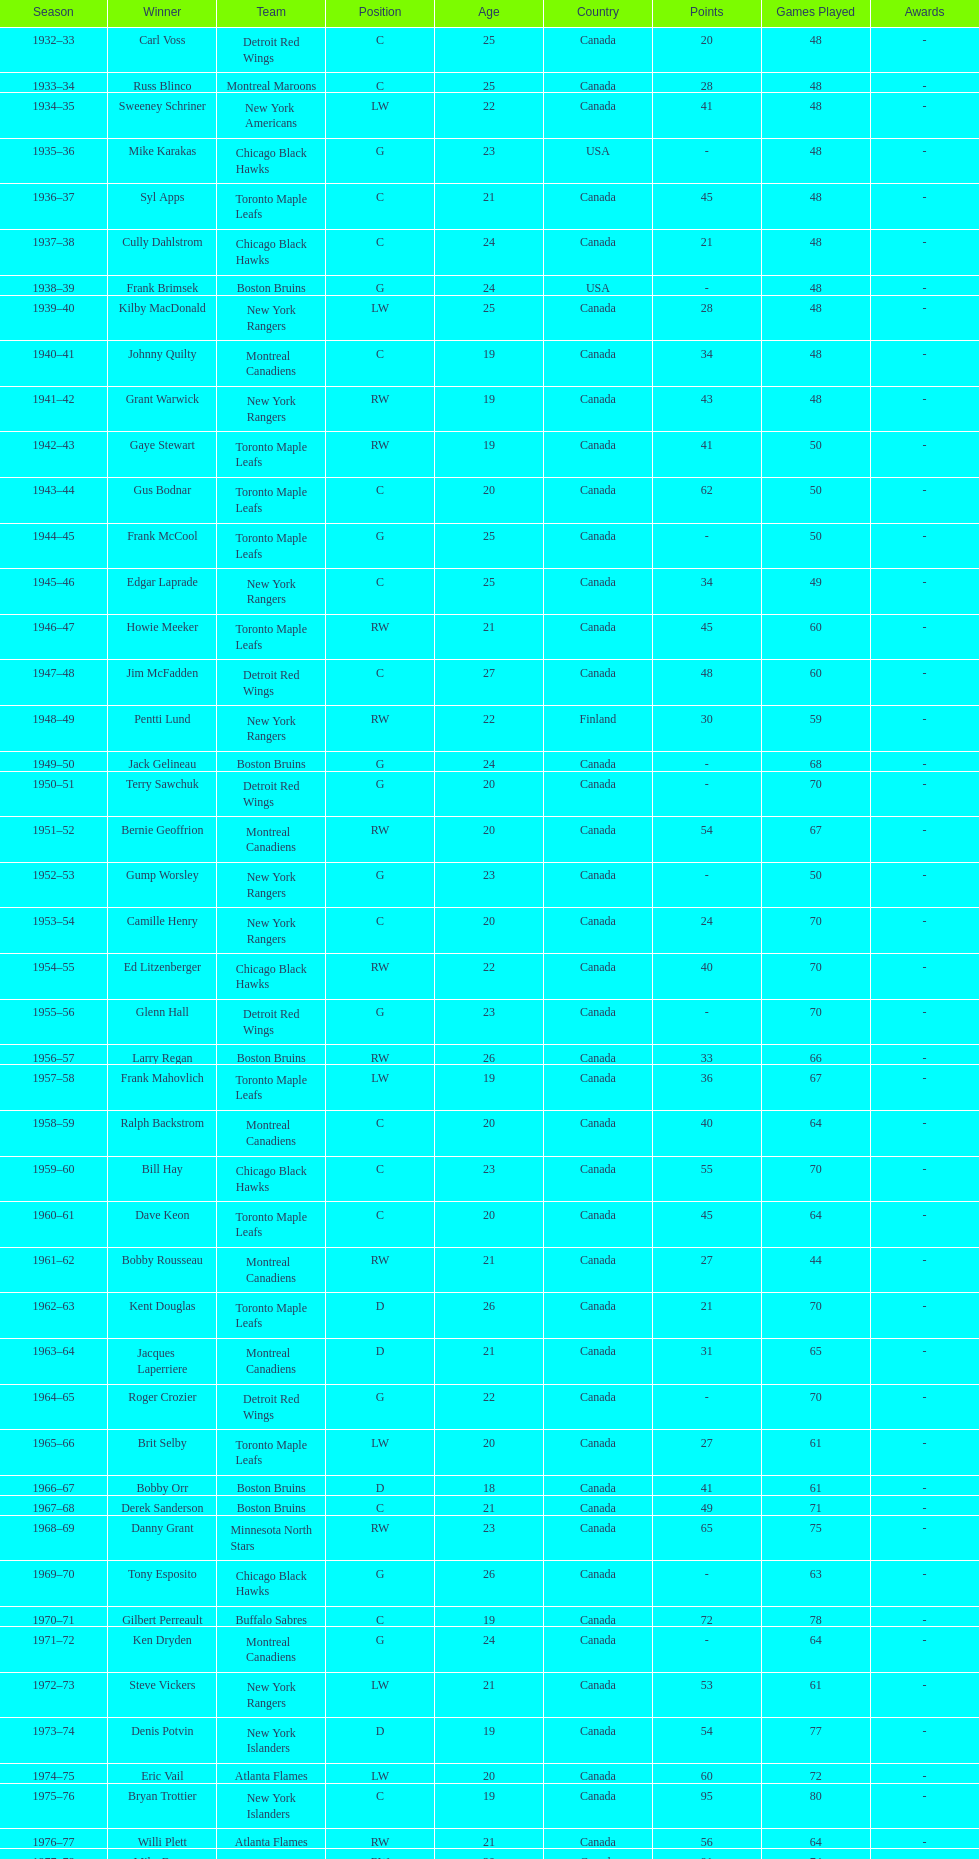Would you mind parsing the complete table? {'header': ['Season', 'Winner', 'Team', 'Position', 'Age', 'Country', 'Points', 'Games Played', 'Awards'], 'rows': [['1932–33', 'Carl Voss', 'Detroit Red Wings', 'C', '25', 'Canada', '20', '48', '-'], ['1933–34', 'Russ Blinco', 'Montreal Maroons', 'C', '25', 'Canada', '28', '48', '-'], ['1934–35', 'Sweeney Schriner', 'New York Americans', 'LW', '22', 'Canada', '41', '48', '-'], ['1935–36', 'Mike Karakas', 'Chicago Black Hawks', 'G', '23', 'USA', '-', '48', '-'], ['1936–37', 'Syl Apps', 'Toronto Maple Leafs', 'C', '21', 'Canada', '45', '48', '-'], ['1937–38', 'Cully Dahlstrom', 'Chicago Black Hawks', 'C', '24', 'Canada', '21', '48', '-'], ['1938–39', 'Frank Brimsek', 'Boston Bruins', 'G', '24', 'USA', '-', '48', '-'], ['1939–40', 'Kilby MacDonald', 'New York Rangers', 'LW', '25', 'Canada', '28', '48', '-'], ['1940–41', 'Johnny Quilty', 'Montreal Canadiens', 'C', '19', 'Canada', '34', '48', '-'], ['1941–42', 'Grant Warwick', 'New York Rangers', 'RW', '19', 'Canada', '43', '48', '-'], ['1942–43', 'Gaye Stewart', 'Toronto Maple Leafs', 'RW', '19', 'Canada', '41', '50', '-'], ['1943–44', 'Gus Bodnar', 'Toronto Maple Leafs', 'C', '20', 'Canada', '62', '50', '-'], ['1944–45', 'Frank McCool', 'Toronto Maple Leafs', 'G', '25', 'Canada', '-', '50', '-'], ['1945–46', 'Edgar Laprade', 'New York Rangers', 'C', '25', 'Canada', '34', '49', '-'], ['1946–47', 'Howie Meeker', 'Toronto Maple Leafs', 'RW', '21', 'Canada', '45', '60', '-'], ['1947–48', 'Jim McFadden', 'Detroit Red Wings', 'C', '27', 'Canada', '48', '60', '-'], ['1948–49', 'Pentti Lund', 'New York Rangers', 'RW', '22', 'Finland', '30', '59', '-'], ['1949–50', 'Jack Gelineau', 'Boston Bruins', 'G', '24', 'Canada', '-', '68', '-'], ['1950–51', 'Terry Sawchuk', 'Detroit Red Wings', 'G', '20', 'Canada', '-', '70', '-'], ['1951–52', 'Bernie Geoffrion', 'Montreal Canadiens', 'RW', '20', 'Canada', '54', '67', '-'], ['1952–53', 'Gump Worsley', 'New York Rangers', 'G', '23', 'Canada', '-', '50', '-'], ['1953–54', 'Camille Henry', 'New York Rangers', 'C', '20', 'Canada', '24', '70', '-'], ['1954–55', 'Ed Litzenberger', 'Chicago Black Hawks', 'RW', '22', 'Canada', '40', '70', '-'], ['1955–56', 'Glenn Hall', 'Detroit Red Wings', 'G', '23', 'Canada', '-', '70', '-'], ['1956–57', 'Larry Regan', 'Boston Bruins', 'RW', '26', 'Canada', '33', '66', '-'], ['1957–58', 'Frank Mahovlich', 'Toronto Maple Leafs', 'LW', '19', 'Canada', '36', '67', '-'], ['1958–59', 'Ralph Backstrom', 'Montreal Canadiens', 'C', '20', 'Canada', '40', '64', '-'], ['1959–60', 'Bill Hay', 'Chicago Black Hawks', 'C', '23', 'Canada', '55', '70', '-'], ['1960–61', 'Dave Keon', 'Toronto Maple Leafs', 'C', '20', 'Canada', '45', '64', '-'], ['1961–62', 'Bobby Rousseau', 'Montreal Canadiens', 'RW', '21', 'Canada', '27', '44', '-'], ['1962–63', 'Kent Douglas', 'Toronto Maple Leafs', 'D', '26', 'Canada', '21', '70', '-'], ['1963–64', 'Jacques Laperriere', 'Montreal Canadiens', 'D', '21', 'Canada', '31', '65', '-'], ['1964–65', 'Roger Crozier', 'Detroit Red Wings', 'G', '22', 'Canada', '-', '70', '-'], ['1965–66', 'Brit Selby', 'Toronto Maple Leafs', 'LW', '20', 'Canada', '27', '61', '-'], ['1966–67', 'Bobby Orr', 'Boston Bruins', 'D', '18', 'Canada', '41', '61', '-'], ['1967–68', 'Derek Sanderson', 'Boston Bruins', 'C', '21', 'Canada', '49', '71', '-'], ['1968–69', 'Danny Grant', 'Minnesota North Stars', 'RW', '23', 'Canada', '65', '75', '-'], ['1969–70', 'Tony Esposito', 'Chicago Black Hawks', 'G', '26', 'Canada', '-', '63', '-'], ['1970–71', 'Gilbert Perreault', 'Buffalo Sabres', 'C', '19', 'Canada', '72', '78', '-'], ['1971–72', 'Ken Dryden', 'Montreal Canadiens', 'G', '24', 'Canada', '-', '64', '-'], ['1972–73', 'Steve Vickers', 'New York Rangers', 'LW', '21', 'Canada', '53', '61', '-'], ['1973–74', 'Denis Potvin', 'New York Islanders', 'D', '19', 'Canada', '54', '77', '-'], ['1974–75', 'Eric Vail', 'Atlanta Flames', 'LW', '20', 'Canada', '60', '72', '-'], ['1975–76', 'Bryan Trottier', 'New York Islanders', 'C', '19', 'Canada', '95', '80', '-'], ['1976–77', 'Willi Plett', 'Atlanta Flames', 'RW', '21', 'Canada', '56', '64', '-'], ['1977–78', 'Mike Bossy', 'New York Islanders', 'RW', '20', 'Canada', '91', '74', '-'], ['1978–79', 'Bobby Smith', 'Minnesota North Stars', 'C', '20', 'Canada', '74', '80', '-'], ['1979–80', 'Ray Bourque', 'Boston Bruins', 'D', '19', 'Canada', '65', '80', '-'], ['1980–81', 'Peter Stastny', 'Quebec Nordiques', 'C', '24', 'Slovakia', '109', '77', '-'], ['1981–82', 'Dale Hawerchuk', 'Winnipeg Jets', 'C', '18', 'Canada', '103', '80', '-'], ['1982–83', 'Steve Larmer', 'Chicago Black Hawks', 'RW', '21', 'Canada', '90', '80', '-'], ['1983–84', 'Tom Barrasso', 'Buffalo Sabres', 'G', '18', 'USA', '-', '42', '-'], ['1984–85', 'Mario Lemieux', 'Pittsburgh Penguins', 'C', '19', 'Canada', '100', '73', '-'], ['1985–86', 'Gary Suter', 'Calgary Flames', 'D', '21', 'USA', '68', '80', '-'], ['1986–87', 'Luc Robitaille', 'Los Angeles Kings', 'LW', '20', 'Canada', '84', '79', '-'], ['1987–88', 'Joe Nieuwendyk', 'Calgary Flames', 'C', '21', 'Canada', '92', '75', '-'], ['1988–89', 'Brian Leetch', 'New York Rangers', 'D', '20', 'USA', '71', '68', '-'], ['1989–90', 'Sergei Makarov', 'Calgary Flames', 'RW', '31', 'Russia', '86', '80', '-'], ['1990–91', 'Ed Belfour', 'Chicago Blackhawks', 'G', '25', 'Canada', '-', '74', '-'], ['1991–92', 'Pavel Bure', 'Vancouver Canucks', 'RW', '20', 'Russia', '60', '65', '-'], ['1992–93', 'Teemu Selanne', 'Winnipeg Jets', 'RW', '22', 'Finland', '132', '84', '-'], ['1993–94', 'Martin Brodeur', 'New Jersey Devils', 'G', '21', 'Canada', '-', '47', '-'], ['1994–95', 'Peter Forsberg', 'Quebec Nordiques', 'C', '21', 'Sweden', '50', '47', '-'], ['1995–96', 'Daniel Alfredsson', 'Ottawa Senators', 'RW', '22', 'Sweden', '61', '82', '-'], ['1996–97', 'Bryan Berard', 'New York Islanders', 'D', '19', 'USA', '48', '82', '-'], ['1997–98', 'Sergei Samsonov', 'Boston Bruins', 'LW', '19', 'Russia', '47', '81', '-'], ['1998–99', 'Chris Drury', 'Colorado Avalanche', 'C', '22', 'USA', '44', '79', '-'], ['1999–2000', 'Scott Gomez', 'New Jersey Devils', 'C', '19', 'USA', '70', '82', '-'], ['2000–01', 'Evgeni Nabokov', 'San Jose Sharks', 'G', '25', 'Russia', '-', '66', '-'], ['2001–02', 'Dany Heatley', 'Atlanta Thrashers', 'RW', '20', 'Canada', '67', '82', '-'], ['2002–03', 'Barret Jackman', 'St. Louis Blues', 'D', '21', 'Canada', '19', '82', '-'], ['2003–04', 'Andrew Raycroft', 'Boston Bruins', 'G', '23', 'Canada', '-', '57', '-'], ['2004–05', 'No winner because of the\\n2004–05 NHL lockout', '-', '-', '-', '-', '-', '-', '-'], ['2005–06', 'Alexander Ovechkin', 'Washington Capitals', 'LW', '20', 'Russia', '106', '81', '-'], ['2006–07', 'Evgeni Malkin', 'Pittsburgh Penguins', 'C', '20', 'Russia', '85', '78', '-'], ['2007–08', 'Patrick Kane', 'Chicago Blackhawks', 'RW', '19', 'USA', '72', '82', '-'], ['2008–09', 'Steve Mason', 'Columbus Blue Jackets', 'G', '21', 'Canada', '-', '61', '-'], ['2009–10', 'Tyler Myers', 'Buffalo Sabres', 'D', '20', 'Canada', '48', '82', '-'], ['2010–11', 'Jeff Skinner', 'Carolina Hurricanes', 'C', '18', 'Canada', '63', '82', '-'], ['2011–12', 'Gabriel Landeskog', 'Colorado Avalanche', 'LW', '19', 'Sweden', '52', '82', '-'], ['2012–13', 'Jonathan Huberdeau', 'Florida Panthers', 'C', '19', 'Canada', '31', '48', '-']]} How many times did the toronto maple leaves win? 9. 